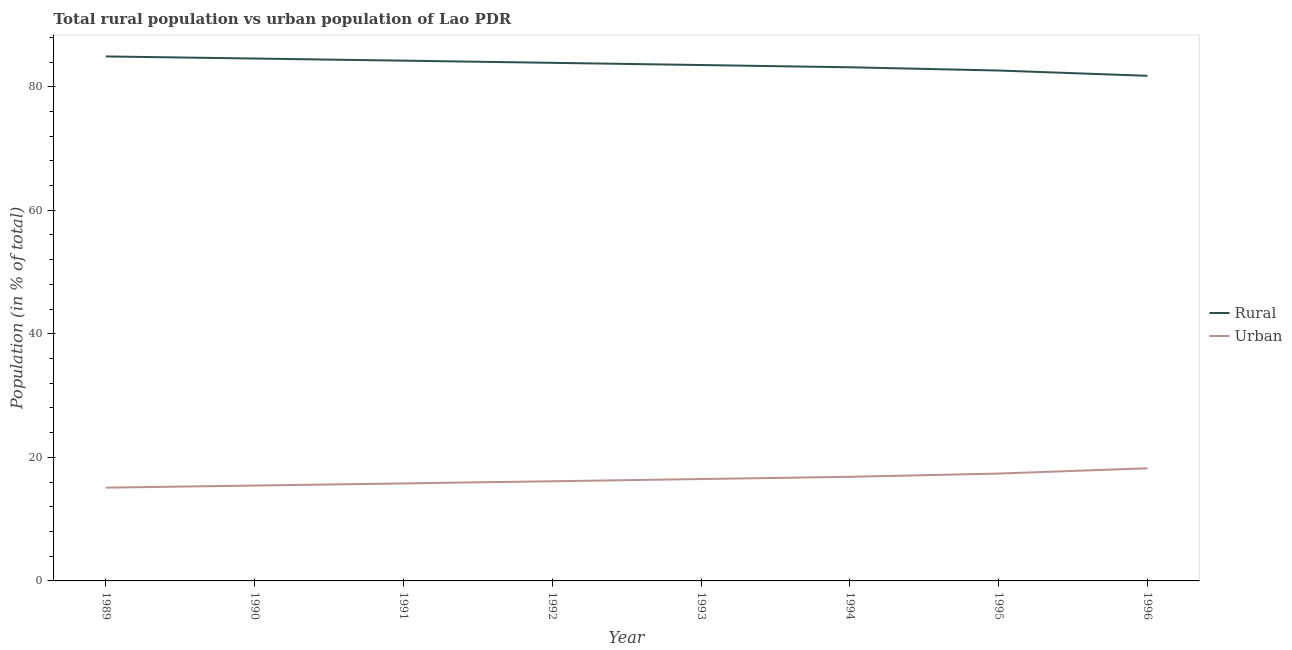How many different coloured lines are there?
Ensure brevity in your answer.  2. What is the urban population in 1996?
Offer a terse response. 18.23. Across all years, what is the maximum urban population?
Your answer should be very brief. 18.23. Across all years, what is the minimum urban population?
Your answer should be compact. 15.1. In which year was the rural population maximum?
Give a very brief answer. 1989. In which year was the urban population minimum?
Your answer should be compact. 1989. What is the total rural population in the graph?
Keep it short and to the point. 668.59. What is the difference between the rural population in 1993 and that in 1995?
Keep it short and to the point. 0.89. What is the difference between the urban population in 1989 and the rural population in 1992?
Ensure brevity in your answer.  -68.77. What is the average rural population per year?
Offer a very short reply. 83.57. In the year 1991, what is the difference between the urban population and rural population?
Provide a succinct answer. -68.44. In how many years, is the urban population greater than 36 %?
Your answer should be compact. 0. What is the ratio of the rural population in 1991 to that in 1996?
Ensure brevity in your answer.  1.03. Is the urban population in 1990 less than that in 1991?
Give a very brief answer. Yes. What is the difference between the highest and the second highest urban population?
Keep it short and to the point. 0.86. What is the difference between the highest and the lowest urban population?
Offer a very short reply. 3.14. Does the urban population monotonically increase over the years?
Make the answer very short. Yes. How many lines are there?
Your answer should be compact. 2. Does the graph contain any zero values?
Give a very brief answer. No. Does the graph contain grids?
Keep it short and to the point. No. Where does the legend appear in the graph?
Your response must be concise. Center right. What is the title of the graph?
Offer a terse response. Total rural population vs urban population of Lao PDR. What is the label or title of the X-axis?
Provide a succinct answer. Year. What is the label or title of the Y-axis?
Provide a succinct answer. Population (in % of total). What is the Population (in % of total) in Rural in 1989?
Your response must be concise. 84.9. What is the Population (in % of total) in Urban in 1989?
Provide a short and direct response. 15.1. What is the Population (in % of total) in Rural in 1990?
Ensure brevity in your answer.  84.56. What is the Population (in % of total) of Urban in 1990?
Offer a very short reply. 15.44. What is the Population (in % of total) of Rural in 1991?
Provide a succinct answer. 84.22. What is the Population (in % of total) of Urban in 1991?
Your answer should be compact. 15.78. What is the Population (in % of total) of Rural in 1992?
Make the answer very short. 83.87. What is the Population (in % of total) of Urban in 1992?
Offer a very short reply. 16.13. What is the Population (in % of total) of Rural in 1993?
Keep it short and to the point. 83.51. What is the Population (in % of total) in Urban in 1993?
Offer a terse response. 16.49. What is the Population (in % of total) in Rural in 1994?
Keep it short and to the point. 83.15. What is the Population (in % of total) of Urban in 1994?
Your answer should be compact. 16.85. What is the Population (in % of total) in Rural in 1995?
Keep it short and to the point. 82.62. What is the Population (in % of total) of Urban in 1995?
Your answer should be very brief. 17.38. What is the Population (in % of total) of Rural in 1996?
Provide a short and direct response. 81.77. What is the Population (in % of total) in Urban in 1996?
Your response must be concise. 18.23. Across all years, what is the maximum Population (in % of total) of Rural?
Keep it short and to the point. 84.9. Across all years, what is the maximum Population (in % of total) of Urban?
Your answer should be very brief. 18.23. Across all years, what is the minimum Population (in % of total) in Rural?
Your response must be concise. 81.77. Across all years, what is the minimum Population (in % of total) in Urban?
Keep it short and to the point. 15.1. What is the total Population (in % of total) of Rural in the graph?
Your answer should be compact. 668.59. What is the total Population (in % of total) of Urban in the graph?
Your answer should be very brief. 131.41. What is the difference between the Population (in % of total) of Rural in 1989 and that in 1990?
Keep it short and to the point. 0.34. What is the difference between the Population (in % of total) in Urban in 1989 and that in 1990?
Ensure brevity in your answer.  -0.34. What is the difference between the Population (in % of total) of Rural in 1989 and that in 1991?
Give a very brief answer. 0.68. What is the difference between the Population (in % of total) in Urban in 1989 and that in 1991?
Offer a terse response. -0.68. What is the difference between the Population (in % of total) of Rural in 1989 and that in 1992?
Offer a terse response. 1.03. What is the difference between the Population (in % of total) of Urban in 1989 and that in 1992?
Offer a terse response. -1.03. What is the difference between the Population (in % of total) of Rural in 1989 and that in 1993?
Offer a terse response. 1.39. What is the difference between the Population (in % of total) in Urban in 1989 and that in 1993?
Ensure brevity in your answer.  -1.39. What is the difference between the Population (in % of total) of Rural in 1989 and that in 1994?
Offer a very short reply. 1.76. What is the difference between the Population (in % of total) in Urban in 1989 and that in 1994?
Your response must be concise. -1.76. What is the difference between the Population (in % of total) in Rural in 1989 and that in 1995?
Give a very brief answer. 2.28. What is the difference between the Population (in % of total) in Urban in 1989 and that in 1995?
Give a very brief answer. -2.28. What is the difference between the Population (in % of total) of Rural in 1989 and that in 1996?
Provide a succinct answer. 3.14. What is the difference between the Population (in % of total) of Urban in 1989 and that in 1996?
Keep it short and to the point. -3.14. What is the difference between the Population (in % of total) in Rural in 1990 and that in 1991?
Make the answer very short. 0.34. What is the difference between the Population (in % of total) of Urban in 1990 and that in 1991?
Keep it short and to the point. -0.34. What is the difference between the Population (in % of total) in Rural in 1990 and that in 1992?
Your answer should be very brief. 0.7. What is the difference between the Population (in % of total) in Urban in 1990 and that in 1992?
Ensure brevity in your answer.  -0.7. What is the difference between the Population (in % of total) in Rural in 1990 and that in 1993?
Your answer should be very brief. 1.05. What is the difference between the Population (in % of total) of Urban in 1990 and that in 1993?
Your response must be concise. -1.05. What is the difference between the Population (in % of total) in Rural in 1990 and that in 1994?
Make the answer very short. 1.42. What is the difference between the Population (in % of total) in Urban in 1990 and that in 1994?
Your answer should be compact. -1.42. What is the difference between the Population (in % of total) in Rural in 1990 and that in 1995?
Provide a short and direct response. 1.94. What is the difference between the Population (in % of total) in Urban in 1990 and that in 1995?
Make the answer very short. -1.94. What is the difference between the Population (in % of total) of Rural in 1990 and that in 1996?
Provide a succinct answer. 2.8. What is the difference between the Population (in % of total) in Urban in 1990 and that in 1996?
Keep it short and to the point. -2.8. What is the difference between the Population (in % of total) in Rural in 1991 and that in 1992?
Provide a succinct answer. 0.35. What is the difference between the Population (in % of total) in Urban in 1991 and that in 1992?
Provide a succinct answer. -0.35. What is the difference between the Population (in % of total) of Rural in 1991 and that in 1993?
Your answer should be very brief. 0.71. What is the difference between the Population (in % of total) in Urban in 1991 and that in 1993?
Offer a very short reply. -0.71. What is the difference between the Population (in % of total) in Rural in 1991 and that in 1994?
Your response must be concise. 1.07. What is the difference between the Population (in % of total) in Urban in 1991 and that in 1994?
Provide a succinct answer. -1.07. What is the difference between the Population (in % of total) of Rural in 1991 and that in 1995?
Give a very brief answer. 1.6. What is the difference between the Population (in % of total) of Urban in 1991 and that in 1995?
Offer a terse response. -1.6. What is the difference between the Population (in % of total) in Rural in 1991 and that in 1996?
Keep it short and to the point. 2.45. What is the difference between the Population (in % of total) of Urban in 1991 and that in 1996?
Your response must be concise. -2.45. What is the difference between the Population (in % of total) in Rural in 1992 and that in 1993?
Make the answer very short. 0.36. What is the difference between the Population (in % of total) of Urban in 1992 and that in 1993?
Your answer should be compact. -0.36. What is the difference between the Population (in % of total) in Rural in 1992 and that in 1994?
Provide a succinct answer. 0.72. What is the difference between the Population (in % of total) in Urban in 1992 and that in 1994?
Make the answer very short. -0.72. What is the difference between the Population (in % of total) of Rural in 1992 and that in 1995?
Provide a short and direct response. 1.25. What is the difference between the Population (in % of total) of Urban in 1992 and that in 1995?
Offer a terse response. -1.25. What is the difference between the Population (in % of total) in Rural in 1992 and that in 1996?
Offer a terse response. 2.1. What is the difference between the Population (in % of total) of Urban in 1992 and that in 1996?
Keep it short and to the point. -2.1. What is the difference between the Population (in % of total) of Rural in 1993 and that in 1994?
Your answer should be very brief. 0.36. What is the difference between the Population (in % of total) in Urban in 1993 and that in 1994?
Keep it short and to the point. -0.36. What is the difference between the Population (in % of total) in Rural in 1993 and that in 1995?
Your answer should be very brief. 0.89. What is the difference between the Population (in % of total) of Urban in 1993 and that in 1995?
Make the answer very short. -0.89. What is the difference between the Population (in % of total) of Rural in 1993 and that in 1996?
Your answer should be very brief. 1.74. What is the difference between the Population (in % of total) of Urban in 1993 and that in 1996?
Your response must be concise. -1.74. What is the difference between the Population (in % of total) of Rural in 1994 and that in 1995?
Your answer should be compact. 0.52. What is the difference between the Population (in % of total) of Urban in 1994 and that in 1995?
Your answer should be compact. -0.52. What is the difference between the Population (in % of total) of Rural in 1994 and that in 1996?
Your answer should be compact. 1.38. What is the difference between the Population (in % of total) in Urban in 1994 and that in 1996?
Offer a terse response. -1.38. What is the difference between the Population (in % of total) of Rural in 1995 and that in 1996?
Keep it short and to the point. 0.86. What is the difference between the Population (in % of total) of Urban in 1995 and that in 1996?
Ensure brevity in your answer.  -0.86. What is the difference between the Population (in % of total) of Rural in 1989 and the Population (in % of total) of Urban in 1990?
Offer a very short reply. 69.47. What is the difference between the Population (in % of total) in Rural in 1989 and the Population (in % of total) in Urban in 1991?
Your answer should be very brief. 69.12. What is the difference between the Population (in % of total) of Rural in 1989 and the Population (in % of total) of Urban in 1992?
Make the answer very short. 68.77. What is the difference between the Population (in % of total) in Rural in 1989 and the Population (in % of total) in Urban in 1993?
Provide a short and direct response. 68.41. What is the difference between the Population (in % of total) in Rural in 1989 and the Population (in % of total) in Urban in 1994?
Ensure brevity in your answer.  68.05. What is the difference between the Population (in % of total) in Rural in 1989 and the Population (in % of total) in Urban in 1995?
Make the answer very short. 67.52. What is the difference between the Population (in % of total) in Rural in 1989 and the Population (in % of total) in Urban in 1996?
Your answer should be compact. 66.67. What is the difference between the Population (in % of total) of Rural in 1990 and the Population (in % of total) of Urban in 1991?
Provide a short and direct response. 68.78. What is the difference between the Population (in % of total) of Rural in 1990 and the Population (in % of total) of Urban in 1992?
Your answer should be very brief. 68.43. What is the difference between the Population (in % of total) in Rural in 1990 and the Population (in % of total) in Urban in 1993?
Your answer should be compact. 68.07. What is the difference between the Population (in % of total) of Rural in 1990 and the Population (in % of total) of Urban in 1994?
Keep it short and to the point. 67.71. What is the difference between the Population (in % of total) in Rural in 1990 and the Population (in % of total) in Urban in 1995?
Your answer should be very brief. 67.19. What is the difference between the Population (in % of total) of Rural in 1990 and the Population (in % of total) of Urban in 1996?
Ensure brevity in your answer.  66.33. What is the difference between the Population (in % of total) of Rural in 1991 and the Population (in % of total) of Urban in 1992?
Your answer should be very brief. 68.08. What is the difference between the Population (in % of total) in Rural in 1991 and the Population (in % of total) in Urban in 1993?
Your response must be concise. 67.73. What is the difference between the Population (in % of total) of Rural in 1991 and the Population (in % of total) of Urban in 1994?
Provide a short and direct response. 67.36. What is the difference between the Population (in % of total) in Rural in 1991 and the Population (in % of total) in Urban in 1995?
Your answer should be very brief. 66.84. What is the difference between the Population (in % of total) in Rural in 1991 and the Population (in % of total) in Urban in 1996?
Make the answer very short. 65.98. What is the difference between the Population (in % of total) in Rural in 1992 and the Population (in % of total) in Urban in 1993?
Ensure brevity in your answer.  67.38. What is the difference between the Population (in % of total) in Rural in 1992 and the Population (in % of total) in Urban in 1994?
Give a very brief answer. 67.01. What is the difference between the Population (in % of total) of Rural in 1992 and the Population (in % of total) of Urban in 1995?
Your answer should be compact. 66.49. What is the difference between the Population (in % of total) in Rural in 1992 and the Population (in % of total) in Urban in 1996?
Provide a short and direct response. 65.63. What is the difference between the Population (in % of total) of Rural in 1993 and the Population (in % of total) of Urban in 1994?
Your response must be concise. 66.66. What is the difference between the Population (in % of total) in Rural in 1993 and the Population (in % of total) in Urban in 1995?
Provide a succinct answer. 66.13. What is the difference between the Population (in % of total) in Rural in 1993 and the Population (in % of total) in Urban in 1996?
Your answer should be very brief. 65.28. What is the difference between the Population (in % of total) in Rural in 1994 and the Population (in % of total) in Urban in 1995?
Keep it short and to the point. 65.77. What is the difference between the Population (in % of total) in Rural in 1994 and the Population (in % of total) in Urban in 1996?
Offer a terse response. 64.91. What is the difference between the Population (in % of total) of Rural in 1995 and the Population (in % of total) of Urban in 1996?
Ensure brevity in your answer.  64.39. What is the average Population (in % of total) of Rural per year?
Offer a terse response. 83.57. What is the average Population (in % of total) of Urban per year?
Offer a very short reply. 16.43. In the year 1989, what is the difference between the Population (in % of total) of Rural and Population (in % of total) of Urban?
Ensure brevity in your answer.  69.8. In the year 1990, what is the difference between the Population (in % of total) of Rural and Population (in % of total) of Urban?
Ensure brevity in your answer.  69.13. In the year 1991, what is the difference between the Population (in % of total) in Rural and Population (in % of total) in Urban?
Keep it short and to the point. 68.44. In the year 1992, what is the difference between the Population (in % of total) in Rural and Population (in % of total) in Urban?
Offer a very short reply. 67.73. In the year 1993, what is the difference between the Population (in % of total) of Rural and Population (in % of total) of Urban?
Make the answer very short. 67.02. In the year 1994, what is the difference between the Population (in % of total) of Rural and Population (in % of total) of Urban?
Keep it short and to the point. 66.29. In the year 1995, what is the difference between the Population (in % of total) in Rural and Population (in % of total) in Urban?
Provide a short and direct response. 65.24. In the year 1996, what is the difference between the Population (in % of total) in Rural and Population (in % of total) in Urban?
Provide a short and direct response. 63.53. What is the ratio of the Population (in % of total) in Rural in 1989 to that in 1991?
Your answer should be very brief. 1.01. What is the ratio of the Population (in % of total) in Urban in 1989 to that in 1991?
Your response must be concise. 0.96. What is the ratio of the Population (in % of total) of Rural in 1989 to that in 1992?
Your answer should be very brief. 1.01. What is the ratio of the Population (in % of total) of Urban in 1989 to that in 1992?
Provide a short and direct response. 0.94. What is the ratio of the Population (in % of total) of Rural in 1989 to that in 1993?
Your answer should be compact. 1.02. What is the ratio of the Population (in % of total) in Urban in 1989 to that in 1993?
Your answer should be compact. 0.92. What is the ratio of the Population (in % of total) in Rural in 1989 to that in 1994?
Make the answer very short. 1.02. What is the ratio of the Population (in % of total) in Urban in 1989 to that in 1994?
Provide a succinct answer. 0.9. What is the ratio of the Population (in % of total) in Rural in 1989 to that in 1995?
Your response must be concise. 1.03. What is the ratio of the Population (in % of total) of Urban in 1989 to that in 1995?
Your answer should be very brief. 0.87. What is the ratio of the Population (in % of total) in Rural in 1989 to that in 1996?
Ensure brevity in your answer.  1.04. What is the ratio of the Population (in % of total) of Urban in 1989 to that in 1996?
Offer a terse response. 0.83. What is the ratio of the Population (in % of total) in Rural in 1990 to that in 1991?
Offer a terse response. 1. What is the ratio of the Population (in % of total) in Urban in 1990 to that in 1991?
Offer a terse response. 0.98. What is the ratio of the Population (in % of total) in Rural in 1990 to that in 1992?
Make the answer very short. 1.01. What is the ratio of the Population (in % of total) of Urban in 1990 to that in 1992?
Provide a short and direct response. 0.96. What is the ratio of the Population (in % of total) in Rural in 1990 to that in 1993?
Provide a succinct answer. 1.01. What is the ratio of the Population (in % of total) of Urban in 1990 to that in 1993?
Provide a short and direct response. 0.94. What is the ratio of the Population (in % of total) of Rural in 1990 to that in 1994?
Make the answer very short. 1.02. What is the ratio of the Population (in % of total) in Urban in 1990 to that in 1994?
Your answer should be compact. 0.92. What is the ratio of the Population (in % of total) of Rural in 1990 to that in 1995?
Your answer should be very brief. 1.02. What is the ratio of the Population (in % of total) of Urban in 1990 to that in 1995?
Your answer should be compact. 0.89. What is the ratio of the Population (in % of total) in Rural in 1990 to that in 1996?
Offer a terse response. 1.03. What is the ratio of the Population (in % of total) of Urban in 1990 to that in 1996?
Give a very brief answer. 0.85. What is the ratio of the Population (in % of total) in Urban in 1991 to that in 1992?
Provide a short and direct response. 0.98. What is the ratio of the Population (in % of total) in Rural in 1991 to that in 1993?
Make the answer very short. 1.01. What is the ratio of the Population (in % of total) in Urban in 1991 to that in 1993?
Offer a very short reply. 0.96. What is the ratio of the Population (in % of total) of Rural in 1991 to that in 1994?
Your answer should be compact. 1.01. What is the ratio of the Population (in % of total) in Urban in 1991 to that in 1994?
Provide a short and direct response. 0.94. What is the ratio of the Population (in % of total) of Rural in 1991 to that in 1995?
Your response must be concise. 1.02. What is the ratio of the Population (in % of total) of Urban in 1991 to that in 1995?
Offer a very short reply. 0.91. What is the ratio of the Population (in % of total) of Urban in 1991 to that in 1996?
Offer a very short reply. 0.87. What is the ratio of the Population (in % of total) of Rural in 1992 to that in 1993?
Provide a short and direct response. 1. What is the ratio of the Population (in % of total) in Urban in 1992 to that in 1993?
Offer a very short reply. 0.98. What is the ratio of the Population (in % of total) of Rural in 1992 to that in 1994?
Give a very brief answer. 1.01. What is the ratio of the Population (in % of total) in Urban in 1992 to that in 1994?
Your response must be concise. 0.96. What is the ratio of the Population (in % of total) in Rural in 1992 to that in 1995?
Provide a succinct answer. 1.02. What is the ratio of the Population (in % of total) in Urban in 1992 to that in 1995?
Make the answer very short. 0.93. What is the ratio of the Population (in % of total) in Rural in 1992 to that in 1996?
Ensure brevity in your answer.  1.03. What is the ratio of the Population (in % of total) in Urban in 1992 to that in 1996?
Provide a succinct answer. 0.88. What is the ratio of the Population (in % of total) in Urban in 1993 to that in 1994?
Provide a short and direct response. 0.98. What is the ratio of the Population (in % of total) of Rural in 1993 to that in 1995?
Offer a very short reply. 1.01. What is the ratio of the Population (in % of total) of Urban in 1993 to that in 1995?
Offer a terse response. 0.95. What is the ratio of the Population (in % of total) in Rural in 1993 to that in 1996?
Ensure brevity in your answer.  1.02. What is the ratio of the Population (in % of total) in Urban in 1993 to that in 1996?
Ensure brevity in your answer.  0.9. What is the ratio of the Population (in % of total) of Rural in 1994 to that in 1995?
Your answer should be compact. 1.01. What is the ratio of the Population (in % of total) of Urban in 1994 to that in 1995?
Offer a very short reply. 0.97. What is the ratio of the Population (in % of total) of Rural in 1994 to that in 1996?
Keep it short and to the point. 1.02. What is the ratio of the Population (in % of total) of Urban in 1994 to that in 1996?
Provide a short and direct response. 0.92. What is the ratio of the Population (in % of total) of Rural in 1995 to that in 1996?
Ensure brevity in your answer.  1.01. What is the ratio of the Population (in % of total) in Urban in 1995 to that in 1996?
Give a very brief answer. 0.95. What is the difference between the highest and the second highest Population (in % of total) of Rural?
Offer a terse response. 0.34. What is the difference between the highest and the second highest Population (in % of total) of Urban?
Your answer should be very brief. 0.86. What is the difference between the highest and the lowest Population (in % of total) in Rural?
Offer a terse response. 3.14. What is the difference between the highest and the lowest Population (in % of total) of Urban?
Make the answer very short. 3.14. 